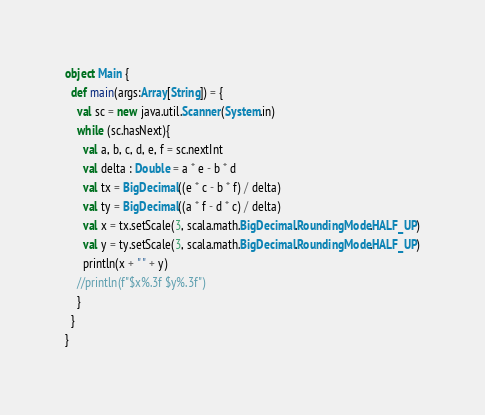Convert code to text. <code><loc_0><loc_0><loc_500><loc_500><_Scala_>object Main {
  def main(args:Array[String]) = {
    val sc = new java.util.Scanner(System.in)
    while (sc.hasNext){
      val a, b, c, d, e, f = sc.nextInt
      val delta : Double = a * e - b * d
      val tx = BigDecimal((e * c - b * f) / delta)
      val ty = BigDecimal((a * f - d * c) / delta)
      val x = tx.setScale(3, scala.math.BigDecimal.RoundingMode.HALF_UP)
      val y = ty.setScale(3, scala.math.BigDecimal.RoundingMode.HALF_UP)
      println(x + " " + y)
    //println(f"$x%.3f $y%.3f")
    }
  }
}</code> 